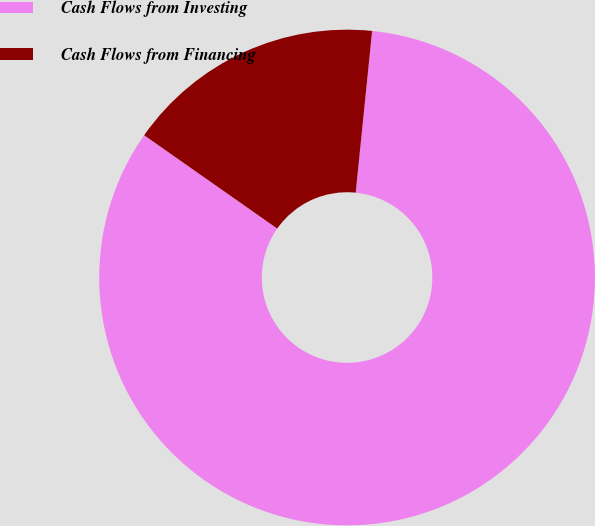Convert chart to OTSL. <chart><loc_0><loc_0><loc_500><loc_500><pie_chart><fcel>Cash Flows from Investing<fcel>Cash Flows from Financing<nl><fcel>83.12%<fcel>16.88%<nl></chart> 